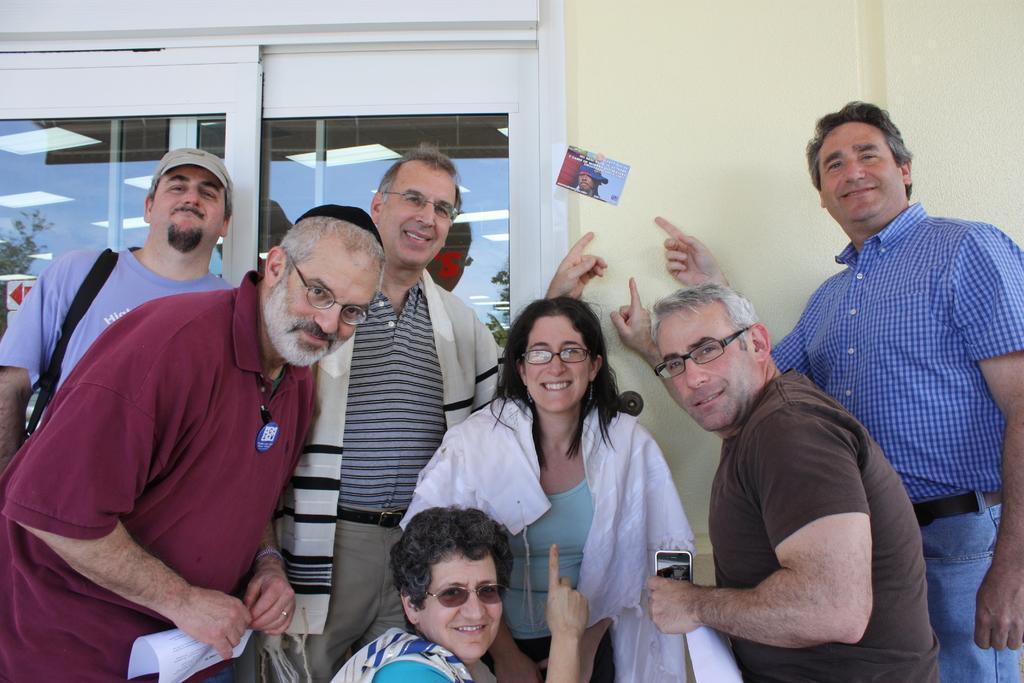In one or two sentences, can you explain what this image depicts? In this picture we can see some people are standing and smiling, in the background there is a wall and glasses, there is a paper pasted on the wall, a person on the left side is holding a paper. 